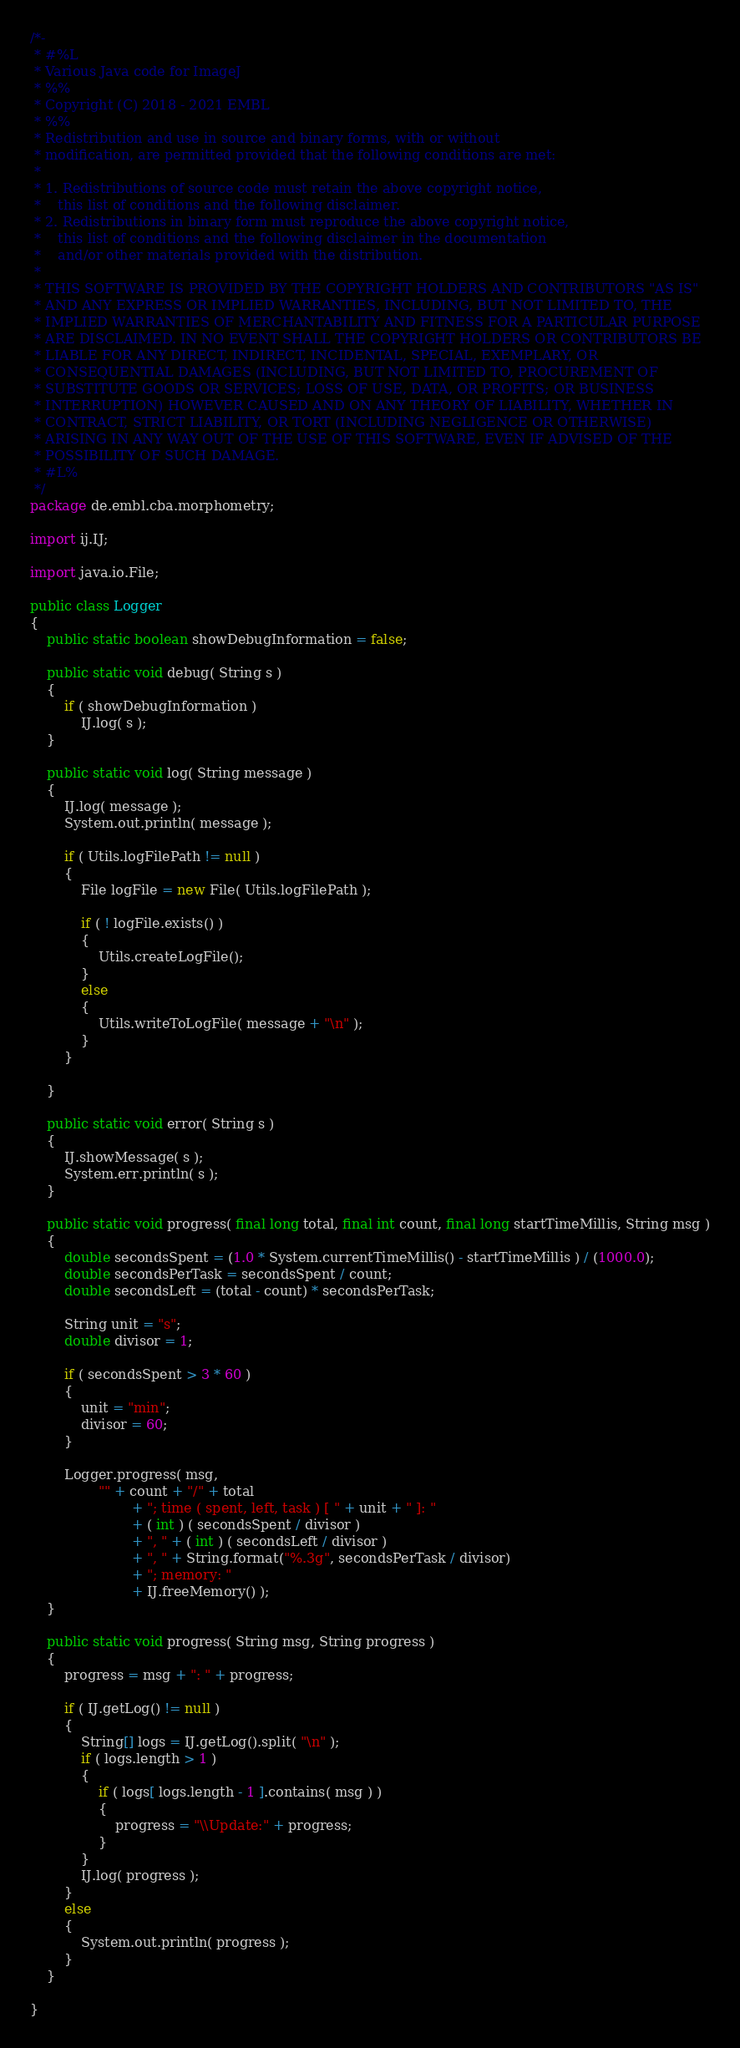<code> <loc_0><loc_0><loc_500><loc_500><_Java_>/*-
 * #%L
 * Various Java code for ImageJ
 * %%
 * Copyright (C) 2018 - 2021 EMBL
 * %%
 * Redistribution and use in source and binary forms, with or without
 * modification, are permitted provided that the following conditions are met:
 * 
 * 1. Redistributions of source code must retain the above copyright notice,
 *    this list of conditions and the following disclaimer.
 * 2. Redistributions in binary form must reproduce the above copyright notice,
 *    this list of conditions and the following disclaimer in the documentation
 *    and/or other materials provided with the distribution.
 * 
 * THIS SOFTWARE IS PROVIDED BY THE COPYRIGHT HOLDERS AND CONTRIBUTORS "AS IS"
 * AND ANY EXPRESS OR IMPLIED WARRANTIES, INCLUDING, BUT NOT LIMITED TO, THE
 * IMPLIED WARRANTIES OF MERCHANTABILITY AND FITNESS FOR A PARTICULAR PURPOSE
 * ARE DISCLAIMED. IN NO EVENT SHALL THE COPYRIGHT HOLDERS OR CONTRIBUTORS BE
 * LIABLE FOR ANY DIRECT, INDIRECT, INCIDENTAL, SPECIAL, EXEMPLARY, OR
 * CONSEQUENTIAL DAMAGES (INCLUDING, BUT NOT LIMITED TO, PROCUREMENT OF
 * SUBSTITUTE GOODS OR SERVICES; LOSS OF USE, DATA, OR PROFITS; OR BUSINESS
 * INTERRUPTION) HOWEVER CAUSED AND ON ANY THEORY OF LIABILITY, WHETHER IN
 * CONTRACT, STRICT LIABILITY, OR TORT (INCLUDING NEGLIGENCE OR OTHERWISE)
 * ARISING IN ANY WAY OUT OF THE USE OF THIS SOFTWARE, EVEN IF ADVISED OF THE
 * POSSIBILITY OF SUCH DAMAGE.
 * #L%
 */
package de.embl.cba.morphometry;

import ij.IJ;

import java.io.File;

public class Logger
{
	public static boolean showDebugInformation = false;

	public static void debug( String s )
	{
		if ( showDebugInformation )
			IJ.log( s );
	}

	public static void log( String message )
	{
		IJ.log( message );
		System.out.println( message );

		if ( Utils.logFilePath != null )
		{
			File logFile = new File( Utils.logFilePath );

			if ( ! logFile.exists() )
			{
				Utils.createLogFile();
			}
			else
			{
				Utils.writeToLogFile( message + "\n" );
			}
		}

	}

	public static void error( String s )
	{
		IJ.showMessage( s );
		System.err.println( s );
	}

	public static void progress( final long total, final int count, final long startTimeMillis, String msg )
	{
		double secondsSpent = (1.0 * System.currentTimeMillis() - startTimeMillis ) / (1000.0);
		double secondsPerTask = secondsSpent / count;
		double secondsLeft = (total - count) * secondsPerTask;

		String unit = "s";
		double divisor = 1;

		if ( secondsSpent > 3 * 60 )
		{
			unit = "min";
			divisor = 60;
		}

		Logger.progress( msg,
				"" + count + "/" + total
						+ "; time ( spent, left, task ) [ " + unit + " ]: "
						+ ( int ) ( secondsSpent / divisor )
						+ ", " + ( int ) ( secondsLeft / divisor )
						+ ", " + String.format("%.3g", secondsPerTask / divisor)
						+ "; memory: "
						+ IJ.freeMemory() );
	}

	public static void progress( String msg, String progress )
	{
		progress = msg + ": " + progress;

		if ( IJ.getLog() != null )
		{
			String[] logs = IJ.getLog().split( "\n" );
			if ( logs.length > 1 )
			{
				if ( logs[ logs.length - 1 ].contains( msg ) )
				{
					progress = "\\Update:" + progress;
				}
			}
			IJ.log( progress );
		}
		else
		{
			System.out.println( progress );
		}
	}

}
</code> 